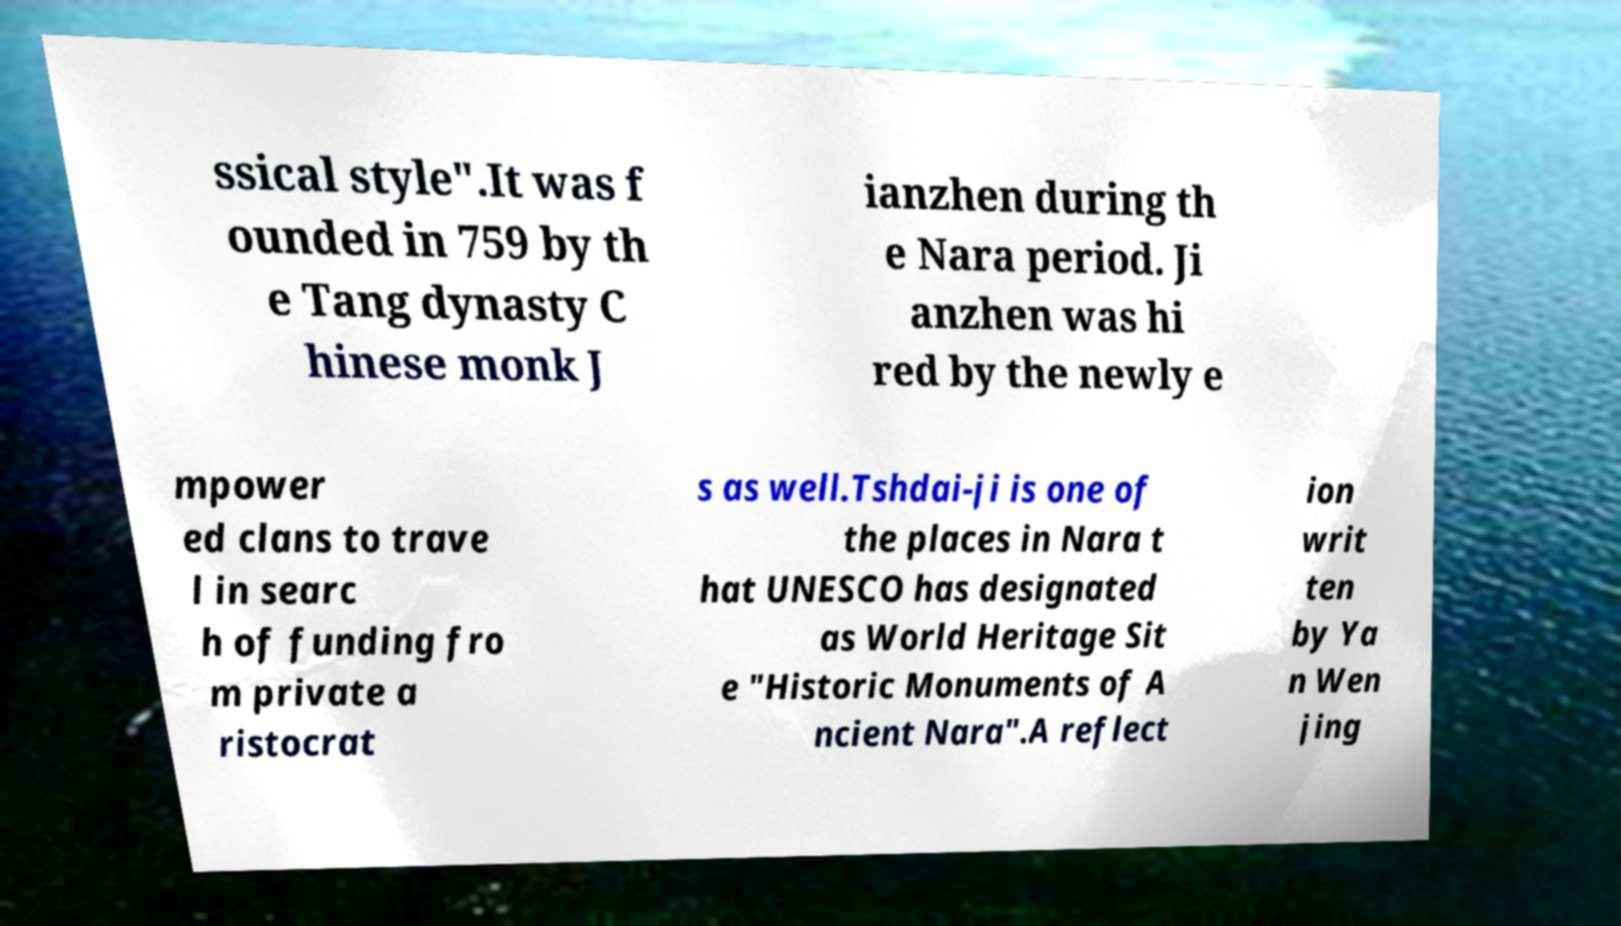For documentation purposes, I need the text within this image transcribed. Could you provide that? ssical style".It was f ounded in 759 by th e Tang dynasty C hinese monk J ianzhen during th e Nara period. Ji anzhen was hi red by the newly e mpower ed clans to trave l in searc h of funding fro m private a ristocrat s as well.Tshdai-ji is one of the places in Nara t hat UNESCO has designated as World Heritage Sit e "Historic Monuments of A ncient Nara".A reflect ion writ ten by Ya n Wen jing 